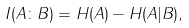<formula> <loc_0><loc_0><loc_500><loc_500>I ( A \colon B ) = H ( A ) - H ( A | B ) ,</formula> 